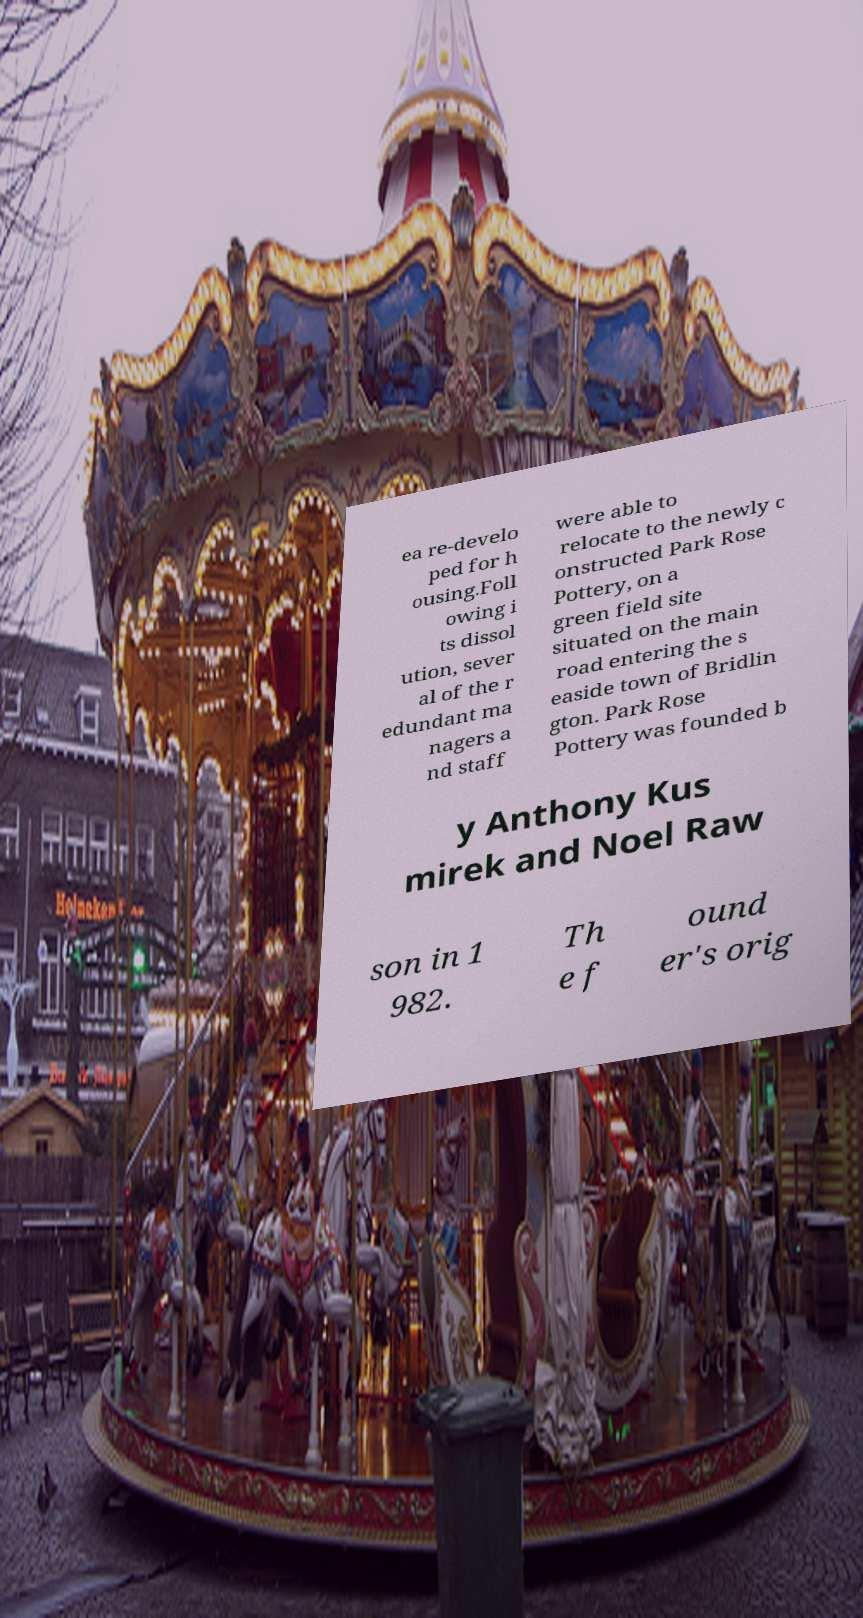I need the written content from this picture converted into text. Can you do that? ea re-develo ped for h ousing.Foll owing i ts dissol ution, sever al of the r edundant ma nagers a nd staff were able to relocate to the newly c onstructed Park Rose Pottery, on a green field site situated on the main road entering the s easide town of Bridlin gton. Park Rose Pottery was founded b y Anthony Kus mirek and Noel Raw son in 1 982. Th e f ound er's orig 